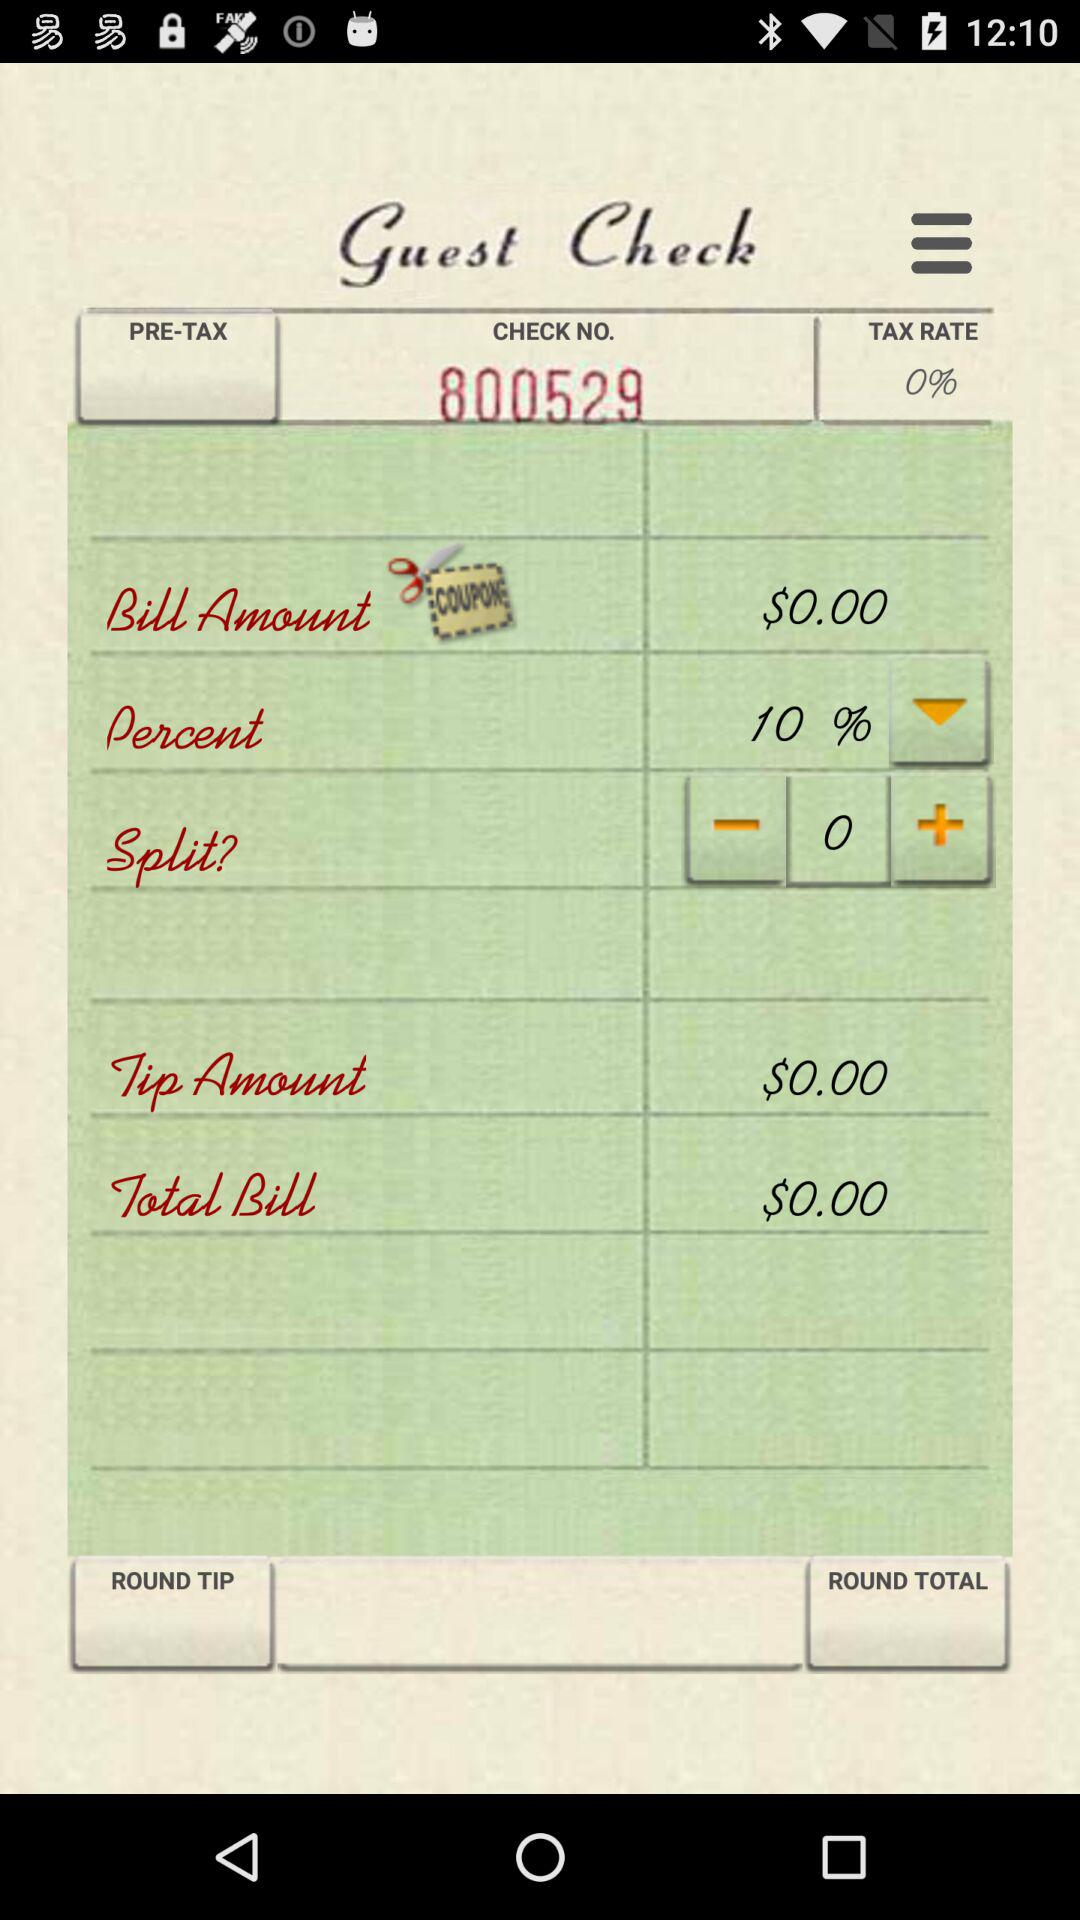What is the total amount of the bill before tax?
Answer the question using a single word or phrase. $0.00 